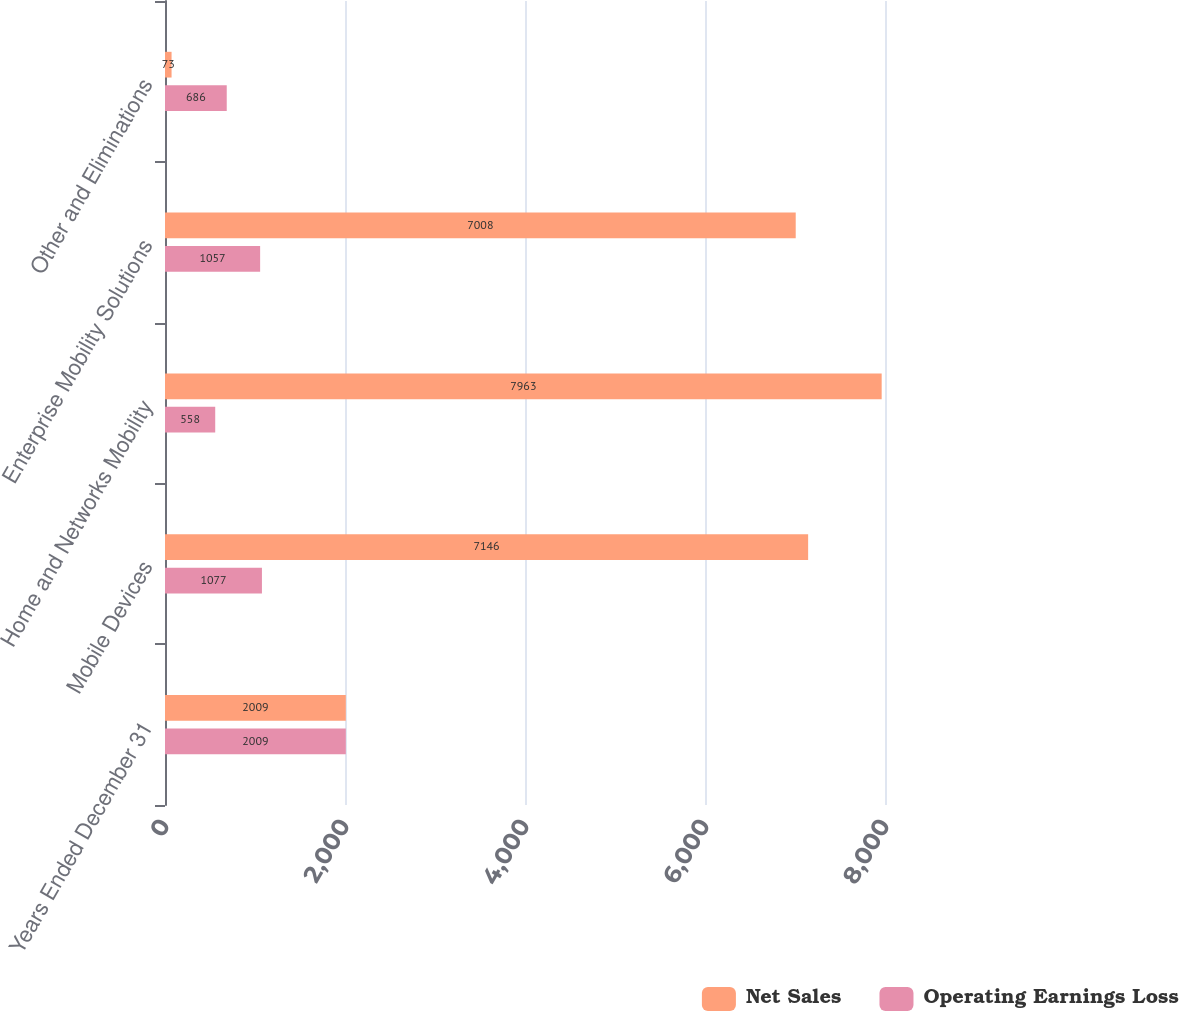<chart> <loc_0><loc_0><loc_500><loc_500><stacked_bar_chart><ecel><fcel>Years Ended December 31<fcel>Mobile Devices<fcel>Home and Networks Mobility<fcel>Enterprise Mobility Solutions<fcel>Other and Eliminations<nl><fcel>Net Sales<fcel>2009<fcel>7146<fcel>7963<fcel>7008<fcel>73<nl><fcel>Operating Earnings Loss<fcel>2009<fcel>1077<fcel>558<fcel>1057<fcel>686<nl></chart> 